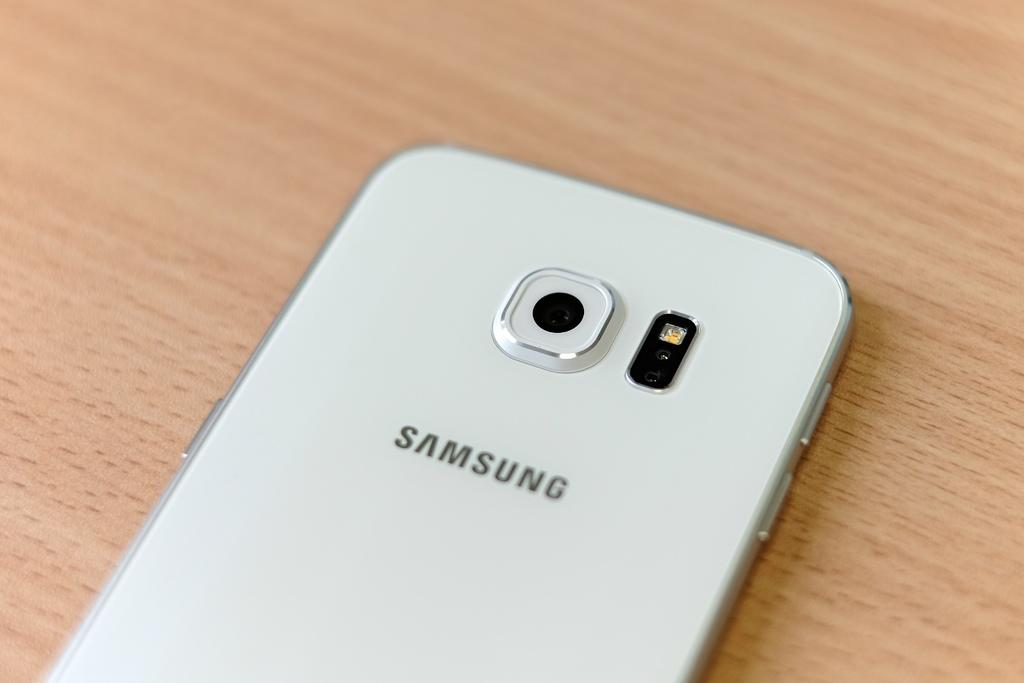Provide a one-sentence caption for the provided image. A white Samsung phone on an oak table. 